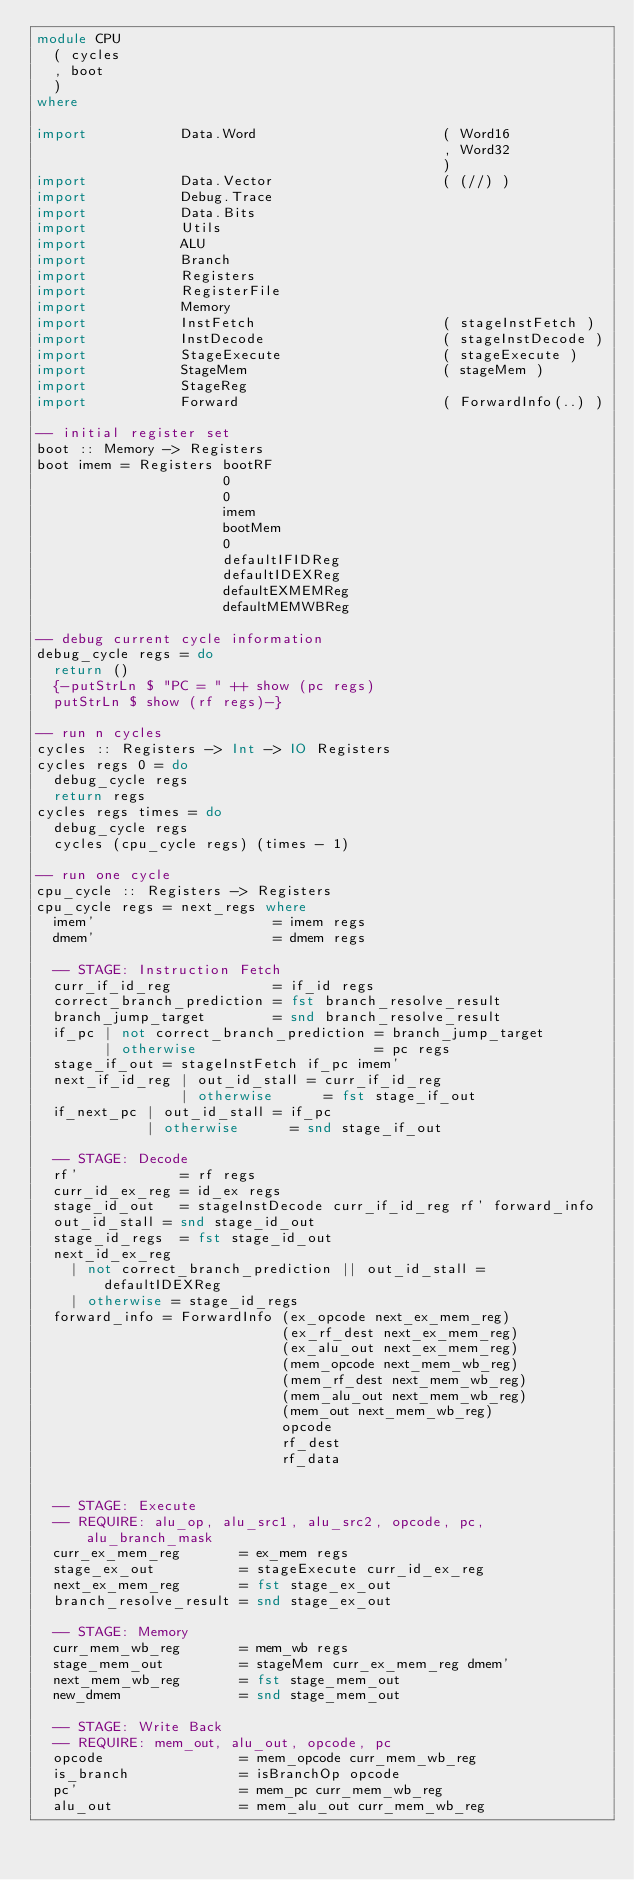<code> <loc_0><loc_0><loc_500><loc_500><_Haskell_>module CPU
  ( cycles
  , boot
  )
where

import           Data.Word                      ( Word16
                                                , Word32
                                                )
import           Data.Vector                    ( (//) )
import           Debug.Trace
import           Data.Bits
import           Utils
import           ALU
import           Branch
import           Registers
import           RegisterFile
import           Memory
import           InstFetch                      ( stageInstFetch )
import           InstDecode                     ( stageInstDecode )
import           StageExecute                   ( stageExecute )
import           StageMem                       ( stageMem )
import           StageReg
import           Forward                        ( ForwardInfo(..) )

-- initial register set
boot :: Memory -> Registers
boot imem = Registers bootRF
                      0
                      0
                      imem
                      bootMem
                      0
                      defaultIFIDReg
                      defaultIDEXReg
                      defaultEXMEMReg
                      defaultMEMWBReg

-- debug current cycle information
debug_cycle regs = do
  return ()
  {-putStrLn $ "PC = " ++ show (pc regs)
  putStrLn $ show (rf regs)-}

-- run n cycles
cycles :: Registers -> Int -> IO Registers
cycles regs 0 = do
  debug_cycle regs
  return regs
cycles regs times = do
  debug_cycle regs
  cycles (cpu_cycle regs) (times - 1)

-- run one cycle
cpu_cycle :: Registers -> Registers
cpu_cycle regs = next_regs where
  imem'                     = imem regs
  dmem'                     = dmem regs

  -- STAGE: Instruction Fetch
  curr_if_id_reg            = if_id regs
  correct_branch_prediction = fst branch_resolve_result
  branch_jump_target        = snd branch_resolve_result
  if_pc | not correct_branch_prediction = branch_jump_target
        | otherwise                     = pc regs
  stage_if_out = stageInstFetch if_pc imem'
  next_if_id_reg | out_id_stall = curr_if_id_reg
                 | otherwise      = fst stage_if_out
  if_next_pc | out_id_stall = if_pc
             | otherwise      = snd stage_if_out

  -- STAGE: Decode
  rf'            = rf regs
  curr_id_ex_reg = id_ex regs
  stage_id_out   = stageInstDecode curr_if_id_reg rf' forward_info
  out_id_stall = snd stage_id_out
  stage_id_regs  = fst stage_id_out
  next_id_ex_reg
    | not correct_branch_prediction || out_id_stall = defaultIDEXReg
    | otherwise = stage_id_regs
  forward_info = ForwardInfo (ex_opcode next_ex_mem_reg)
                             (ex_rf_dest next_ex_mem_reg)
                             (ex_alu_out next_ex_mem_reg)
                             (mem_opcode next_mem_wb_reg)
                             (mem_rf_dest next_mem_wb_reg)
                             (mem_alu_out next_mem_wb_reg)
                             (mem_out next_mem_wb_reg)
                             opcode
                             rf_dest
                             rf_data


  -- STAGE: Execute
  -- REQUIRE: alu_op, alu_src1, alu_src2, opcode, pc, alu_branch_mask
  curr_ex_mem_reg       = ex_mem regs
  stage_ex_out          = stageExecute curr_id_ex_reg
  next_ex_mem_reg       = fst stage_ex_out
  branch_resolve_result = snd stage_ex_out

  -- STAGE: Memory
  curr_mem_wb_reg       = mem_wb regs
  stage_mem_out         = stageMem curr_ex_mem_reg dmem'
  next_mem_wb_reg       = fst stage_mem_out
  new_dmem              = snd stage_mem_out

  -- STAGE: Write Back
  -- REQUIRE: mem_out, alu_out, opcode, pc
  opcode                = mem_opcode curr_mem_wb_reg
  is_branch             = isBranchOp opcode
  pc'                   = mem_pc curr_mem_wb_reg
  alu_out               = mem_alu_out curr_mem_wb_reg</code> 